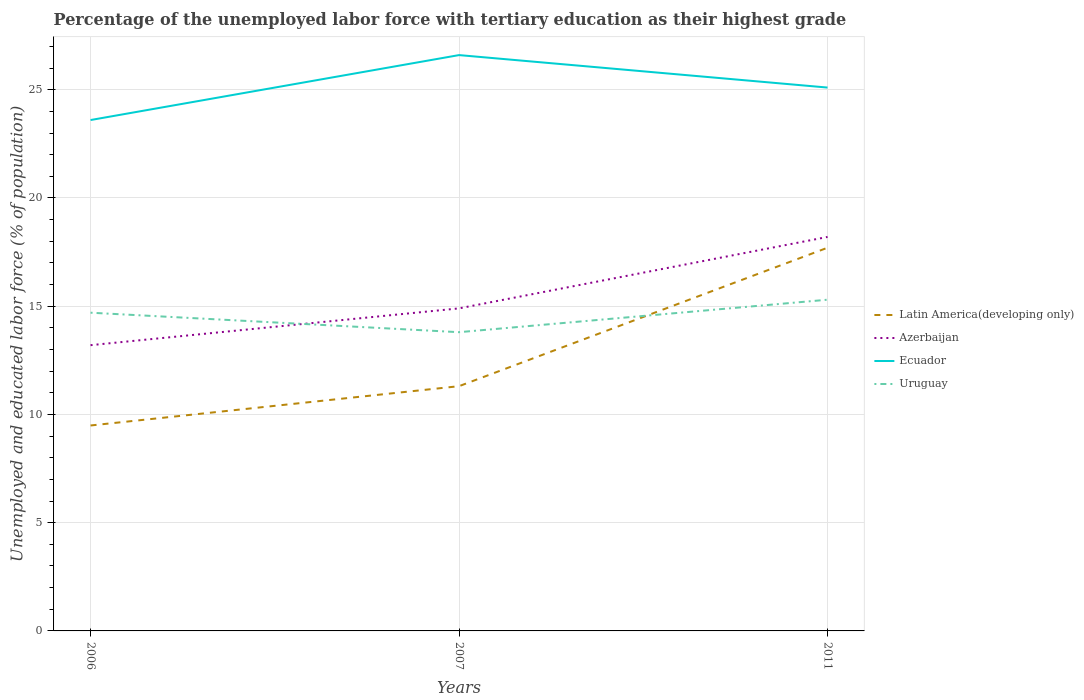How many different coloured lines are there?
Your response must be concise. 4. Across all years, what is the maximum percentage of the unemployed labor force with tertiary education in Azerbaijan?
Ensure brevity in your answer.  13.2. In which year was the percentage of the unemployed labor force with tertiary education in Uruguay maximum?
Offer a very short reply. 2007. What is the total percentage of the unemployed labor force with tertiary education in Latin America(developing only) in the graph?
Offer a terse response. -6.4. What is the difference between the highest and the lowest percentage of the unemployed labor force with tertiary education in Ecuador?
Make the answer very short. 2. How many lines are there?
Make the answer very short. 4. How many years are there in the graph?
Offer a very short reply. 3. What is the difference between two consecutive major ticks on the Y-axis?
Ensure brevity in your answer.  5. Are the values on the major ticks of Y-axis written in scientific E-notation?
Keep it short and to the point. No. Does the graph contain grids?
Provide a short and direct response. Yes. Where does the legend appear in the graph?
Your answer should be compact. Center right. How many legend labels are there?
Your answer should be compact. 4. How are the legend labels stacked?
Provide a succinct answer. Vertical. What is the title of the graph?
Make the answer very short. Percentage of the unemployed labor force with tertiary education as their highest grade. Does "United Arab Emirates" appear as one of the legend labels in the graph?
Provide a succinct answer. No. What is the label or title of the X-axis?
Keep it short and to the point. Years. What is the label or title of the Y-axis?
Your response must be concise. Unemployed and educated labor force (% of population). What is the Unemployed and educated labor force (% of population) in Latin America(developing only) in 2006?
Give a very brief answer. 9.49. What is the Unemployed and educated labor force (% of population) of Azerbaijan in 2006?
Provide a short and direct response. 13.2. What is the Unemployed and educated labor force (% of population) of Ecuador in 2006?
Your answer should be compact. 23.6. What is the Unemployed and educated labor force (% of population) in Uruguay in 2006?
Offer a terse response. 14.7. What is the Unemployed and educated labor force (% of population) in Latin America(developing only) in 2007?
Keep it short and to the point. 11.31. What is the Unemployed and educated labor force (% of population) in Azerbaijan in 2007?
Your answer should be compact. 14.9. What is the Unemployed and educated labor force (% of population) of Ecuador in 2007?
Your answer should be very brief. 26.6. What is the Unemployed and educated labor force (% of population) in Uruguay in 2007?
Offer a terse response. 13.8. What is the Unemployed and educated labor force (% of population) of Latin America(developing only) in 2011?
Offer a very short reply. 17.7. What is the Unemployed and educated labor force (% of population) in Azerbaijan in 2011?
Provide a succinct answer. 18.2. What is the Unemployed and educated labor force (% of population) in Ecuador in 2011?
Your answer should be very brief. 25.1. What is the Unemployed and educated labor force (% of population) in Uruguay in 2011?
Offer a terse response. 15.3. Across all years, what is the maximum Unemployed and educated labor force (% of population) of Latin America(developing only)?
Provide a succinct answer. 17.7. Across all years, what is the maximum Unemployed and educated labor force (% of population) in Azerbaijan?
Your answer should be compact. 18.2. Across all years, what is the maximum Unemployed and educated labor force (% of population) in Ecuador?
Your answer should be very brief. 26.6. Across all years, what is the maximum Unemployed and educated labor force (% of population) in Uruguay?
Your answer should be compact. 15.3. Across all years, what is the minimum Unemployed and educated labor force (% of population) of Latin America(developing only)?
Your answer should be very brief. 9.49. Across all years, what is the minimum Unemployed and educated labor force (% of population) in Azerbaijan?
Your answer should be compact. 13.2. Across all years, what is the minimum Unemployed and educated labor force (% of population) of Ecuador?
Your answer should be compact. 23.6. Across all years, what is the minimum Unemployed and educated labor force (% of population) in Uruguay?
Keep it short and to the point. 13.8. What is the total Unemployed and educated labor force (% of population) in Latin America(developing only) in the graph?
Your answer should be compact. 38.5. What is the total Unemployed and educated labor force (% of population) in Azerbaijan in the graph?
Keep it short and to the point. 46.3. What is the total Unemployed and educated labor force (% of population) of Ecuador in the graph?
Offer a very short reply. 75.3. What is the total Unemployed and educated labor force (% of population) in Uruguay in the graph?
Ensure brevity in your answer.  43.8. What is the difference between the Unemployed and educated labor force (% of population) in Latin America(developing only) in 2006 and that in 2007?
Ensure brevity in your answer.  -1.82. What is the difference between the Unemployed and educated labor force (% of population) in Azerbaijan in 2006 and that in 2007?
Give a very brief answer. -1.7. What is the difference between the Unemployed and educated labor force (% of population) in Ecuador in 2006 and that in 2007?
Your response must be concise. -3. What is the difference between the Unemployed and educated labor force (% of population) of Uruguay in 2006 and that in 2007?
Your response must be concise. 0.9. What is the difference between the Unemployed and educated labor force (% of population) of Latin America(developing only) in 2006 and that in 2011?
Give a very brief answer. -8.21. What is the difference between the Unemployed and educated labor force (% of population) in Latin America(developing only) in 2007 and that in 2011?
Provide a short and direct response. -6.4. What is the difference between the Unemployed and educated labor force (% of population) in Latin America(developing only) in 2006 and the Unemployed and educated labor force (% of population) in Azerbaijan in 2007?
Offer a very short reply. -5.41. What is the difference between the Unemployed and educated labor force (% of population) of Latin America(developing only) in 2006 and the Unemployed and educated labor force (% of population) of Ecuador in 2007?
Your answer should be very brief. -17.11. What is the difference between the Unemployed and educated labor force (% of population) in Latin America(developing only) in 2006 and the Unemployed and educated labor force (% of population) in Uruguay in 2007?
Ensure brevity in your answer.  -4.31. What is the difference between the Unemployed and educated labor force (% of population) of Latin America(developing only) in 2006 and the Unemployed and educated labor force (% of population) of Azerbaijan in 2011?
Offer a terse response. -8.71. What is the difference between the Unemployed and educated labor force (% of population) of Latin America(developing only) in 2006 and the Unemployed and educated labor force (% of population) of Ecuador in 2011?
Your response must be concise. -15.61. What is the difference between the Unemployed and educated labor force (% of population) in Latin America(developing only) in 2006 and the Unemployed and educated labor force (% of population) in Uruguay in 2011?
Ensure brevity in your answer.  -5.81. What is the difference between the Unemployed and educated labor force (% of population) of Azerbaijan in 2006 and the Unemployed and educated labor force (% of population) of Uruguay in 2011?
Your response must be concise. -2.1. What is the difference between the Unemployed and educated labor force (% of population) in Ecuador in 2006 and the Unemployed and educated labor force (% of population) in Uruguay in 2011?
Provide a succinct answer. 8.3. What is the difference between the Unemployed and educated labor force (% of population) of Latin America(developing only) in 2007 and the Unemployed and educated labor force (% of population) of Azerbaijan in 2011?
Make the answer very short. -6.89. What is the difference between the Unemployed and educated labor force (% of population) in Latin America(developing only) in 2007 and the Unemployed and educated labor force (% of population) in Ecuador in 2011?
Ensure brevity in your answer.  -13.79. What is the difference between the Unemployed and educated labor force (% of population) of Latin America(developing only) in 2007 and the Unemployed and educated labor force (% of population) of Uruguay in 2011?
Your answer should be very brief. -3.99. What is the difference between the Unemployed and educated labor force (% of population) in Azerbaijan in 2007 and the Unemployed and educated labor force (% of population) in Ecuador in 2011?
Your answer should be compact. -10.2. What is the difference between the Unemployed and educated labor force (% of population) of Ecuador in 2007 and the Unemployed and educated labor force (% of population) of Uruguay in 2011?
Offer a terse response. 11.3. What is the average Unemployed and educated labor force (% of population) in Latin America(developing only) per year?
Offer a very short reply. 12.83. What is the average Unemployed and educated labor force (% of population) of Azerbaijan per year?
Give a very brief answer. 15.43. What is the average Unemployed and educated labor force (% of population) of Ecuador per year?
Ensure brevity in your answer.  25.1. In the year 2006, what is the difference between the Unemployed and educated labor force (% of population) in Latin America(developing only) and Unemployed and educated labor force (% of population) in Azerbaijan?
Keep it short and to the point. -3.71. In the year 2006, what is the difference between the Unemployed and educated labor force (% of population) of Latin America(developing only) and Unemployed and educated labor force (% of population) of Ecuador?
Provide a succinct answer. -14.11. In the year 2006, what is the difference between the Unemployed and educated labor force (% of population) in Latin America(developing only) and Unemployed and educated labor force (% of population) in Uruguay?
Provide a succinct answer. -5.21. In the year 2006, what is the difference between the Unemployed and educated labor force (% of population) in Azerbaijan and Unemployed and educated labor force (% of population) in Uruguay?
Provide a short and direct response. -1.5. In the year 2006, what is the difference between the Unemployed and educated labor force (% of population) of Ecuador and Unemployed and educated labor force (% of population) of Uruguay?
Your answer should be compact. 8.9. In the year 2007, what is the difference between the Unemployed and educated labor force (% of population) of Latin America(developing only) and Unemployed and educated labor force (% of population) of Azerbaijan?
Your answer should be compact. -3.59. In the year 2007, what is the difference between the Unemployed and educated labor force (% of population) of Latin America(developing only) and Unemployed and educated labor force (% of population) of Ecuador?
Make the answer very short. -15.29. In the year 2007, what is the difference between the Unemployed and educated labor force (% of population) of Latin America(developing only) and Unemployed and educated labor force (% of population) of Uruguay?
Your answer should be compact. -2.49. In the year 2007, what is the difference between the Unemployed and educated labor force (% of population) of Azerbaijan and Unemployed and educated labor force (% of population) of Uruguay?
Offer a terse response. 1.1. In the year 2007, what is the difference between the Unemployed and educated labor force (% of population) in Ecuador and Unemployed and educated labor force (% of population) in Uruguay?
Your answer should be very brief. 12.8. In the year 2011, what is the difference between the Unemployed and educated labor force (% of population) of Latin America(developing only) and Unemployed and educated labor force (% of population) of Azerbaijan?
Your response must be concise. -0.5. In the year 2011, what is the difference between the Unemployed and educated labor force (% of population) in Latin America(developing only) and Unemployed and educated labor force (% of population) in Ecuador?
Offer a terse response. -7.4. In the year 2011, what is the difference between the Unemployed and educated labor force (% of population) of Latin America(developing only) and Unemployed and educated labor force (% of population) of Uruguay?
Your response must be concise. 2.4. In the year 2011, what is the difference between the Unemployed and educated labor force (% of population) in Azerbaijan and Unemployed and educated labor force (% of population) in Uruguay?
Give a very brief answer. 2.9. What is the ratio of the Unemployed and educated labor force (% of population) of Latin America(developing only) in 2006 to that in 2007?
Make the answer very short. 0.84. What is the ratio of the Unemployed and educated labor force (% of population) in Azerbaijan in 2006 to that in 2007?
Your answer should be compact. 0.89. What is the ratio of the Unemployed and educated labor force (% of population) of Ecuador in 2006 to that in 2007?
Make the answer very short. 0.89. What is the ratio of the Unemployed and educated labor force (% of population) in Uruguay in 2006 to that in 2007?
Keep it short and to the point. 1.07. What is the ratio of the Unemployed and educated labor force (% of population) of Latin America(developing only) in 2006 to that in 2011?
Offer a very short reply. 0.54. What is the ratio of the Unemployed and educated labor force (% of population) of Azerbaijan in 2006 to that in 2011?
Offer a terse response. 0.73. What is the ratio of the Unemployed and educated labor force (% of population) of Ecuador in 2006 to that in 2011?
Provide a short and direct response. 0.94. What is the ratio of the Unemployed and educated labor force (% of population) of Uruguay in 2006 to that in 2011?
Provide a succinct answer. 0.96. What is the ratio of the Unemployed and educated labor force (% of population) of Latin America(developing only) in 2007 to that in 2011?
Provide a short and direct response. 0.64. What is the ratio of the Unemployed and educated labor force (% of population) in Azerbaijan in 2007 to that in 2011?
Offer a very short reply. 0.82. What is the ratio of the Unemployed and educated labor force (% of population) of Ecuador in 2007 to that in 2011?
Your answer should be compact. 1.06. What is the ratio of the Unemployed and educated labor force (% of population) of Uruguay in 2007 to that in 2011?
Offer a very short reply. 0.9. What is the difference between the highest and the second highest Unemployed and educated labor force (% of population) in Latin America(developing only)?
Ensure brevity in your answer.  6.4. What is the difference between the highest and the second highest Unemployed and educated labor force (% of population) of Ecuador?
Your answer should be very brief. 1.5. What is the difference between the highest and the lowest Unemployed and educated labor force (% of population) in Latin America(developing only)?
Keep it short and to the point. 8.21. 